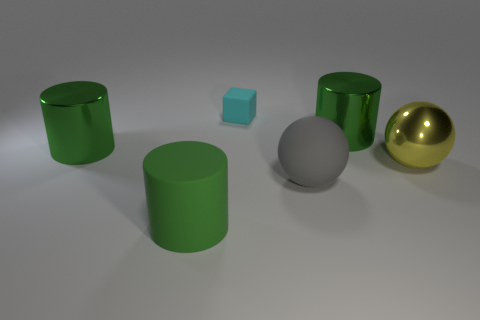Is there anything else that is the same material as the large yellow thing?
Give a very brief answer. Yes. How big is the green metallic thing that is to the left of the cylinder right of the tiny cyan cube?
Offer a terse response. Large. There is a big cylinder that is behind the big gray ball and left of the gray thing; what color is it?
Offer a terse response. Green. Is the shape of the large green matte thing the same as the yellow metal object?
Make the answer very short. No. What is the shape of the green metal object right of the green cylinder to the left of the rubber cylinder?
Your response must be concise. Cylinder. There is a large gray rubber object; does it have the same shape as the thing that is in front of the gray matte sphere?
Your answer should be compact. No. There is a sphere that is the same size as the gray rubber object; what is its color?
Provide a succinct answer. Yellow. Is the number of blocks that are in front of the big green rubber cylinder less than the number of cyan cubes in front of the tiny thing?
Give a very brief answer. No. What shape is the large thing behind the big green shiny cylinder on the left side of the metal cylinder right of the small cyan thing?
Offer a very short reply. Cylinder. There is a large metal object to the left of the tiny thing; does it have the same color as the big cylinder that is on the right side of the rubber cube?
Provide a short and direct response. Yes. 